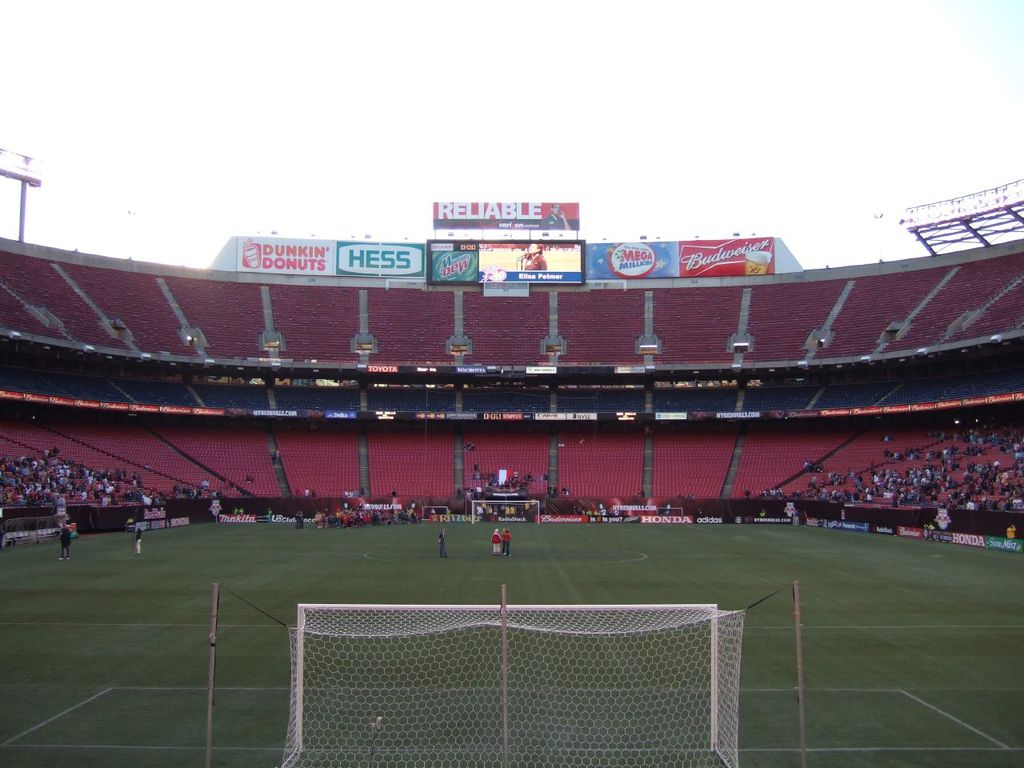What kind of event is taking place in this stadium, and how can you tell? The event is a soccer match, identifiable by the soccer goalposts and the players on the field, visibly engaged in a game. 